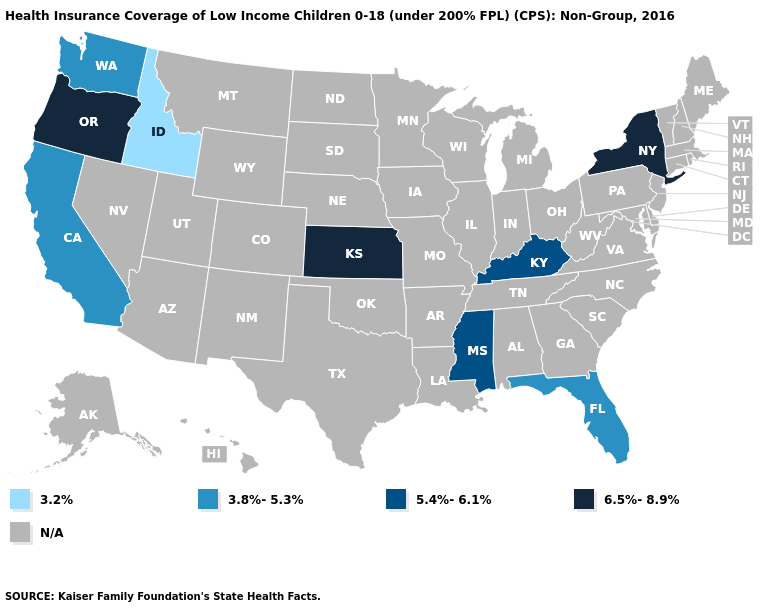Which states have the lowest value in the USA?
Be succinct. Idaho. Which states have the lowest value in the USA?
Be succinct. Idaho. What is the value of South Dakota?
Keep it brief. N/A. What is the lowest value in the South?
Be succinct. 3.8%-5.3%. Does Kentucky have the highest value in the South?
Be succinct. Yes. Does California have the highest value in the USA?
Quick response, please. No. What is the value of North Carolina?
Keep it brief. N/A. Is the legend a continuous bar?
Quick response, please. No. What is the value of Hawaii?
Answer briefly. N/A. Which states have the lowest value in the West?
Be succinct. Idaho. Name the states that have a value in the range N/A?
Concise answer only. Alabama, Alaska, Arizona, Arkansas, Colorado, Connecticut, Delaware, Georgia, Hawaii, Illinois, Indiana, Iowa, Louisiana, Maine, Maryland, Massachusetts, Michigan, Minnesota, Missouri, Montana, Nebraska, Nevada, New Hampshire, New Jersey, New Mexico, North Carolina, North Dakota, Ohio, Oklahoma, Pennsylvania, Rhode Island, South Carolina, South Dakota, Tennessee, Texas, Utah, Vermont, Virginia, West Virginia, Wisconsin, Wyoming. What is the lowest value in the MidWest?
Quick response, please. 6.5%-8.9%. Name the states that have a value in the range 3.8%-5.3%?
Concise answer only. California, Florida, Washington. Which states have the lowest value in the MidWest?
Keep it brief. Kansas. 